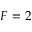Convert formula to latex. <formula><loc_0><loc_0><loc_500><loc_500>F = 2</formula> 